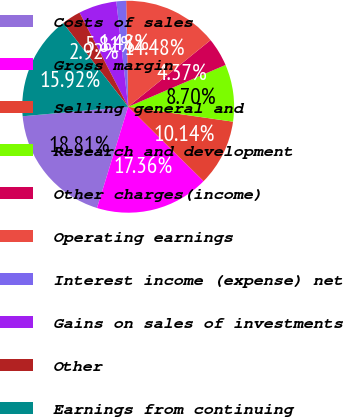Convert chart to OTSL. <chart><loc_0><loc_0><loc_500><loc_500><pie_chart><fcel>Costs of sales<fcel>Gross margin<fcel>Selling general and<fcel>Research and development<fcel>Other charges(income)<fcel>Operating earnings<fcel>Interest income (expense) net<fcel>Gains on sales of investments<fcel>Other<fcel>Earnings from continuing<nl><fcel>18.81%<fcel>17.36%<fcel>10.14%<fcel>8.7%<fcel>4.37%<fcel>14.48%<fcel>1.48%<fcel>5.81%<fcel>2.92%<fcel>15.92%<nl></chart> 